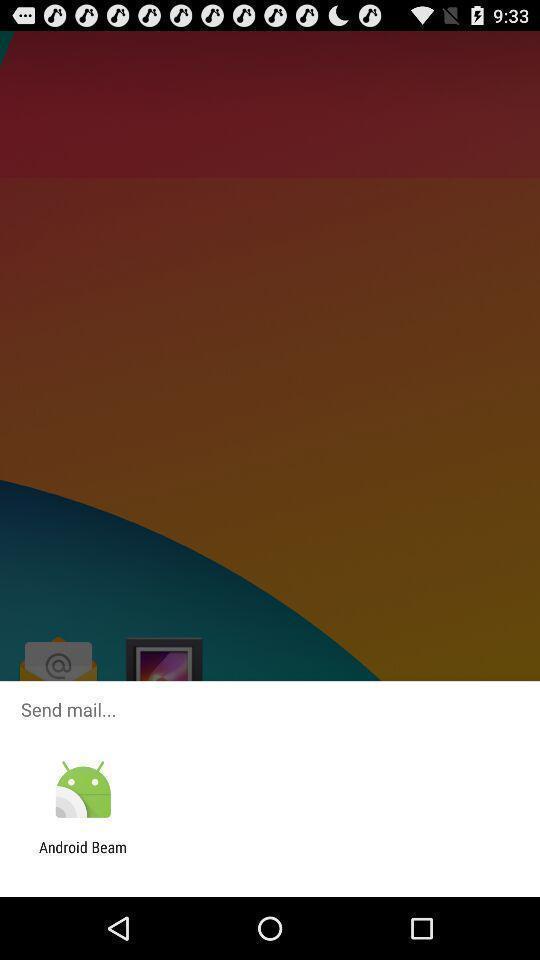Describe the content in this image. Send mail through the app. 